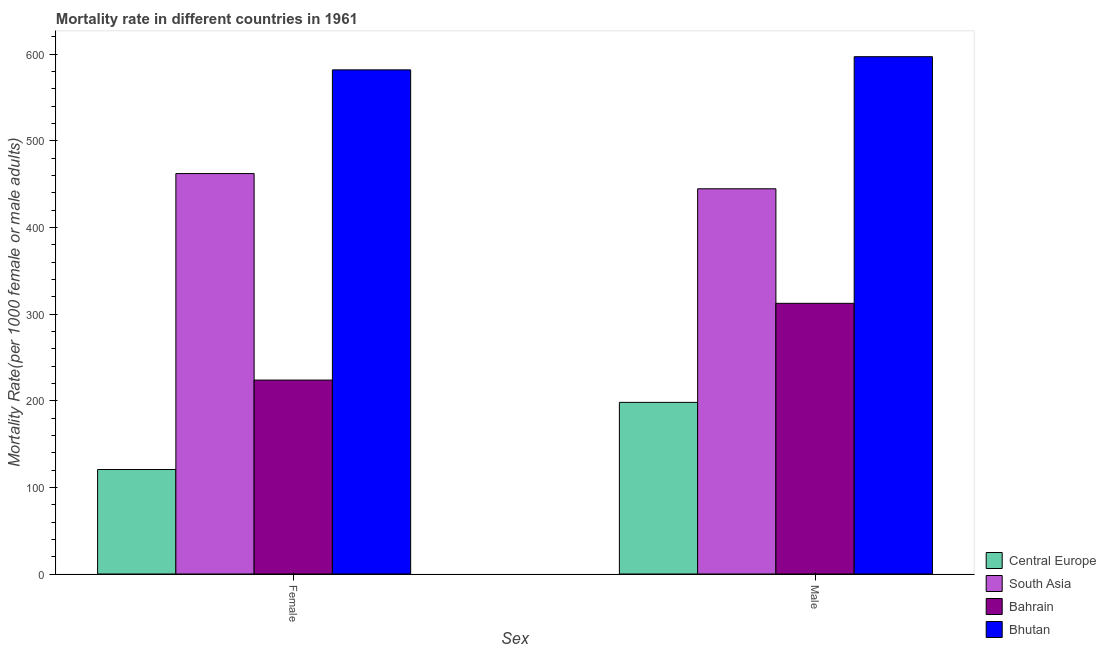How many groups of bars are there?
Keep it short and to the point. 2. Are the number of bars on each tick of the X-axis equal?
Provide a succinct answer. Yes. How many bars are there on the 1st tick from the left?
Provide a short and direct response. 4. What is the label of the 2nd group of bars from the left?
Offer a very short reply. Male. What is the female mortality rate in South Asia?
Provide a short and direct response. 462.19. Across all countries, what is the maximum male mortality rate?
Make the answer very short. 597.09. Across all countries, what is the minimum female mortality rate?
Your answer should be very brief. 120.59. In which country was the male mortality rate maximum?
Your answer should be compact. Bhutan. In which country was the male mortality rate minimum?
Keep it short and to the point. Central Europe. What is the total male mortality rate in the graph?
Your answer should be compact. 1552.22. What is the difference between the male mortality rate in Bahrain and that in South Asia?
Offer a very short reply. -132.19. What is the difference between the male mortality rate in Bhutan and the female mortality rate in South Asia?
Give a very brief answer. 134.9. What is the average female mortality rate per country?
Provide a short and direct response. 347.12. What is the difference between the female mortality rate and male mortality rate in Bhutan?
Your response must be concise. -15.21. What is the ratio of the male mortality rate in South Asia to that in Central Europe?
Your answer should be compact. 2.24. Is the male mortality rate in Bahrain less than that in Central Europe?
Offer a terse response. No. What does the 4th bar from the right in Female represents?
Offer a very short reply. Central Europe. Are all the bars in the graph horizontal?
Your answer should be compact. No. How many countries are there in the graph?
Your answer should be very brief. 4. Are the values on the major ticks of Y-axis written in scientific E-notation?
Give a very brief answer. No. Does the graph contain any zero values?
Keep it short and to the point. No. Does the graph contain grids?
Your answer should be very brief. No. Where does the legend appear in the graph?
Make the answer very short. Bottom right. How many legend labels are there?
Your response must be concise. 4. How are the legend labels stacked?
Your answer should be very brief. Vertical. What is the title of the graph?
Your answer should be very brief. Mortality rate in different countries in 1961. What is the label or title of the X-axis?
Provide a short and direct response. Sex. What is the label or title of the Y-axis?
Your response must be concise. Mortality Rate(per 1000 female or male adults). What is the Mortality Rate(per 1000 female or male adults) of Central Europe in Female?
Give a very brief answer. 120.59. What is the Mortality Rate(per 1000 female or male adults) in South Asia in Female?
Your answer should be compact. 462.19. What is the Mortality Rate(per 1000 female or male adults) in Bahrain in Female?
Give a very brief answer. 223.84. What is the Mortality Rate(per 1000 female or male adults) in Bhutan in Female?
Offer a terse response. 581.88. What is the Mortality Rate(per 1000 female or male adults) of Central Europe in Male?
Your answer should be compact. 198.1. What is the Mortality Rate(per 1000 female or male adults) in South Asia in Male?
Keep it short and to the point. 444.61. What is the Mortality Rate(per 1000 female or male adults) in Bahrain in Male?
Provide a short and direct response. 312.42. What is the Mortality Rate(per 1000 female or male adults) of Bhutan in Male?
Make the answer very short. 597.09. Across all Sex, what is the maximum Mortality Rate(per 1000 female or male adults) of Central Europe?
Keep it short and to the point. 198.1. Across all Sex, what is the maximum Mortality Rate(per 1000 female or male adults) in South Asia?
Keep it short and to the point. 462.19. Across all Sex, what is the maximum Mortality Rate(per 1000 female or male adults) of Bahrain?
Offer a very short reply. 312.42. Across all Sex, what is the maximum Mortality Rate(per 1000 female or male adults) of Bhutan?
Provide a succinct answer. 597.09. Across all Sex, what is the minimum Mortality Rate(per 1000 female or male adults) of Central Europe?
Provide a succinct answer. 120.59. Across all Sex, what is the minimum Mortality Rate(per 1000 female or male adults) in South Asia?
Ensure brevity in your answer.  444.61. Across all Sex, what is the minimum Mortality Rate(per 1000 female or male adults) of Bahrain?
Make the answer very short. 223.84. Across all Sex, what is the minimum Mortality Rate(per 1000 female or male adults) in Bhutan?
Offer a terse response. 581.88. What is the total Mortality Rate(per 1000 female or male adults) in Central Europe in the graph?
Provide a succinct answer. 318.69. What is the total Mortality Rate(per 1000 female or male adults) in South Asia in the graph?
Keep it short and to the point. 906.8. What is the total Mortality Rate(per 1000 female or male adults) in Bahrain in the graph?
Your answer should be very brief. 536.26. What is the total Mortality Rate(per 1000 female or male adults) in Bhutan in the graph?
Give a very brief answer. 1178.97. What is the difference between the Mortality Rate(per 1000 female or male adults) of Central Europe in Female and that in Male?
Ensure brevity in your answer.  -77.51. What is the difference between the Mortality Rate(per 1000 female or male adults) of South Asia in Female and that in Male?
Offer a terse response. 17.57. What is the difference between the Mortality Rate(per 1000 female or male adults) in Bahrain in Female and that in Male?
Provide a succinct answer. -88.58. What is the difference between the Mortality Rate(per 1000 female or male adults) of Bhutan in Female and that in Male?
Offer a very short reply. -15.21. What is the difference between the Mortality Rate(per 1000 female or male adults) in Central Europe in Female and the Mortality Rate(per 1000 female or male adults) in South Asia in Male?
Your response must be concise. -324.02. What is the difference between the Mortality Rate(per 1000 female or male adults) in Central Europe in Female and the Mortality Rate(per 1000 female or male adults) in Bahrain in Male?
Your response must be concise. -191.83. What is the difference between the Mortality Rate(per 1000 female or male adults) of Central Europe in Female and the Mortality Rate(per 1000 female or male adults) of Bhutan in Male?
Offer a very short reply. -476.5. What is the difference between the Mortality Rate(per 1000 female or male adults) in South Asia in Female and the Mortality Rate(per 1000 female or male adults) in Bahrain in Male?
Ensure brevity in your answer.  149.76. What is the difference between the Mortality Rate(per 1000 female or male adults) of South Asia in Female and the Mortality Rate(per 1000 female or male adults) of Bhutan in Male?
Provide a short and direct response. -134.9. What is the difference between the Mortality Rate(per 1000 female or male adults) of Bahrain in Female and the Mortality Rate(per 1000 female or male adults) of Bhutan in Male?
Keep it short and to the point. -373.25. What is the average Mortality Rate(per 1000 female or male adults) in Central Europe per Sex?
Provide a short and direct response. 159.34. What is the average Mortality Rate(per 1000 female or male adults) in South Asia per Sex?
Your answer should be compact. 453.4. What is the average Mortality Rate(per 1000 female or male adults) in Bahrain per Sex?
Ensure brevity in your answer.  268.13. What is the average Mortality Rate(per 1000 female or male adults) of Bhutan per Sex?
Make the answer very short. 589.48. What is the difference between the Mortality Rate(per 1000 female or male adults) in Central Europe and Mortality Rate(per 1000 female or male adults) in South Asia in Female?
Provide a succinct answer. -341.6. What is the difference between the Mortality Rate(per 1000 female or male adults) in Central Europe and Mortality Rate(per 1000 female or male adults) in Bahrain in Female?
Your answer should be compact. -103.25. What is the difference between the Mortality Rate(per 1000 female or male adults) in Central Europe and Mortality Rate(per 1000 female or male adults) in Bhutan in Female?
Your answer should be compact. -461.29. What is the difference between the Mortality Rate(per 1000 female or male adults) in South Asia and Mortality Rate(per 1000 female or male adults) in Bahrain in Female?
Keep it short and to the point. 238.34. What is the difference between the Mortality Rate(per 1000 female or male adults) in South Asia and Mortality Rate(per 1000 female or male adults) in Bhutan in Female?
Your answer should be compact. -119.69. What is the difference between the Mortality Rate(per 1000 female or male adults) in Bahrain and Mortality Rate(per 1000 female or male adults) in Bhutan in Female?
Provide a short and direct response. -358.04. What is the difference between the Mortality Rate(per 1000 female or male adults) in Central Europe and Mortality Rate(per 1000 female or male adults) in South Asia in Male?
Ensure brevity in your answer.  -246.51. What is the difference between the Mortality Rate(per 1000 female or male adults) in Central Europe and Mortality Rate(per 1000 female or male adults) in Bahrain in Male?
Your answer should be very brief. -114.33. What is the difference between the Mortality Rate(per 1000 female or male adults) of Central Europe and Mortality Rate(per 1000 female or male adults) of Bhutan in Male?
Offer a very short reply. -398.99. What is the difference between the Mortality Rate(per 1000 female or male adults) of South Asia and Mortality Rate(per 1000 female or male adults) of Bahrain in Male?
Provide a succinct answer. 132.19. What is the difference between the Mortality Rate(per 1000 female or male adults) of South Asia and Mortality Rate(per 1000 female or male adults) of Bhutan in Male?
Provide a short and direct response. -152.48. What is the difference between the Mortality Rate(per 1000 female or male adults) in Bahrain and Mortality Rate(per 1000 female or male adults) in Bhutan in Male?
Give a very brief answer. -284.67. What is the ratio of the Mortality Rate(per 1000 female or male adults) of Central Europe in Female to that in Male?
Your response must be concise. 0.61. What is the ratio of the Mortality Rate(per 1000 female or male adults) of South Asia in Female to that in Male?
Keep it short and to the point. 1.04. What is the ratio of the Mortality Rate(per 1000 female or male adults) in Bahrain in Female to that in Male?
Your answer should be very brief. 0.72. What is the ratio of the Mortality Rate(per 1000 female or male adults) in Bhutan in Female to that in Male?
Offer a terse response. 0.97. What is the difference between the highest and the second highest Mortality Rate(per 1000 female or male adults) of Central Europe?
Your response must be concise. 77.51. What is the difference between the highest and the second highest Mortality Rate(per 1000 female or male adults) of South Asia?
Offer a terse response. 17.57. What is the difference between the highest and the second highest Mortality Rate(per 1000 female or male adults) of Bahrain?
Your response must be concise. 88.58. What is the difference between the highest and the second highest Mortality Rate(per 1000 female or male adults) in Bhutan?
Make the answer very short. 15.21. What is the difference between the highest and the lowest Mortality Rate(per 1000 female or male adults) of Central Europe?
Keep it short and to the point. 77.51. What is the difference between the highest and the lowest Mortality Rate(per 1000 female or male adults) in South Asia?
Ensure brevity in your answer.  17.57. What is the difference between the highest and the lowest Mortality Rate(per 1000 female or male adults) in Bahrain?
Provide a succinct answer. 88.58. What is the difference between the highest and the lowest Mortality Rate(per 1000 female or male adults) in Bhutan?
Provide a short and direct response. 15.21. 